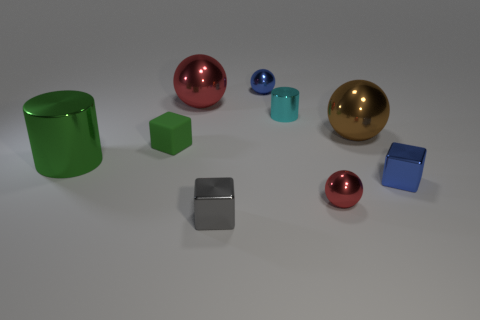Is there a big object of the same color as the tiny rubber thing?
Ensure brevity in your answer.  Yes. The green matte thing is what size?
Provide a succinct answer. Small. Are the small cyan thing and the brown object made of the same material?
Give a very brief answer. Yes. What number of metallic balls are right of the blue metal object in front of the tiny metal thing that is behind the small cylinder?
Offer a very short reply. 0. There is a blue thing that is in front of the green matte cube; what shape is it?
Offer a very short reply. Cube. What number of other objects are the same material as the blue sphere?
Provide a succinct answer. 7. Is the color of the matte block the same as the big cylinder?
Ensure brevity in your answer.  Yes. Is the number of tiny cyan metal things right of the brown metallic thing less than the number of small blue balls that are on the left side of the green metal thing?
Your answer should be compact. No. There is another big thing that is the same shape as the big brown object; what is its color?
Your response must be concise. Red. There is a red ball on the left side of the gray shiny object; is its size the same as the tiny green object?
Your answer should be very brief. No. 